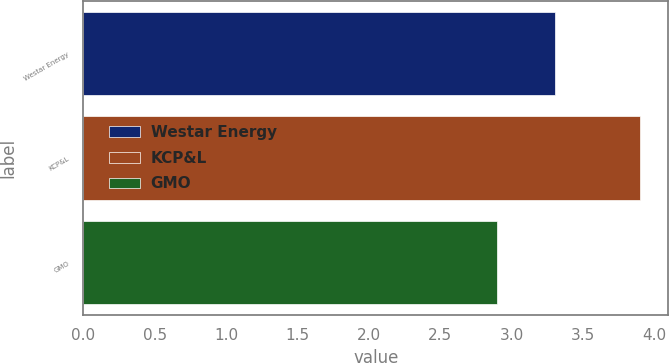Convert chart to OTSL. <chart><loc_0><loc_0><loc_500><loc_500><bar_chart><fcel>Westar Energy<fcel>KCP&L<fcel>GMO<nl><fcel>3.3<fcel>3.9<fcel>2.9<nl></chart> 